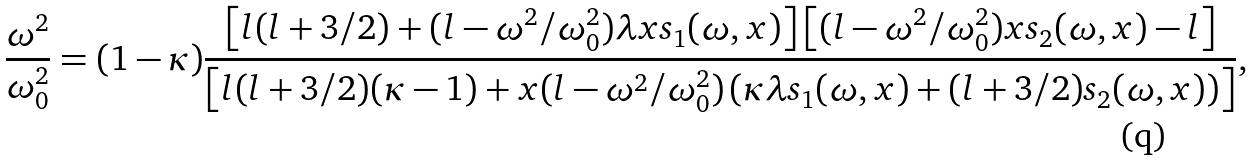<formula> <loc_0><loc_0><loc_500><loc_500>\frac { \omega ^ { 2 } } { \omega _ { 0 } ^ { 2 } } = ( 1 - \kappa ) \frac { \left [ l ( l + 3 / 2 ) + ( l - \omega ^ { 2 } / \omega _ { 0 } ^ { 2 } ) \lambda x s _ { 1 } ( \omega , x ) \right ] \left [ ( l - \omega ^ { 2 } / \omega _ { 0 } ^ { 2 } ) x s _ { 2 } ( \omega , x ) - l \right ] } { \left [ l ( l + 3 / 2 ) ( \kappa - 1 ) + x ( l - \omega ^ { 2 } / \omega _ { 0 } ^ { 2 } ) \left ( \kappa \lambda s _ { 1 } ( \omega , x ) + ( l + 3 / 2 ) s _ { 2 } ( \omega , x ) \right ) \right ] } ,</formula> 